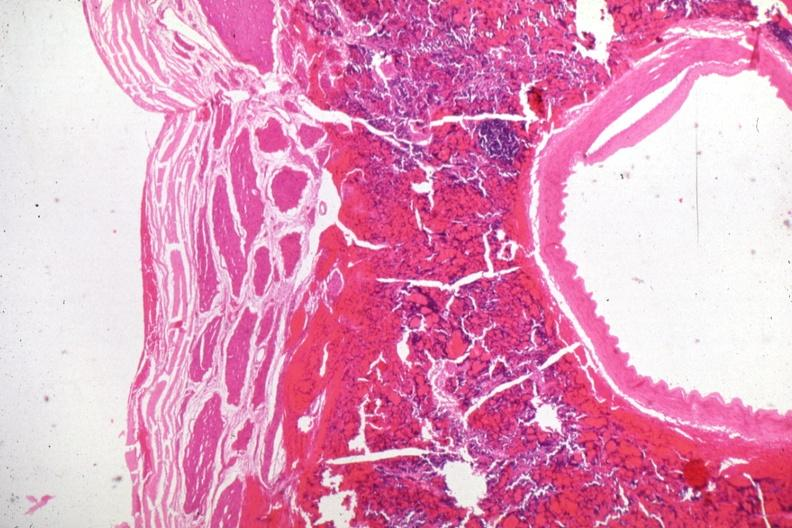does lateral view show carotid artery in region of pituitary with tumor cells in soft tissue?
Answer the question using a single word or phrase. No 